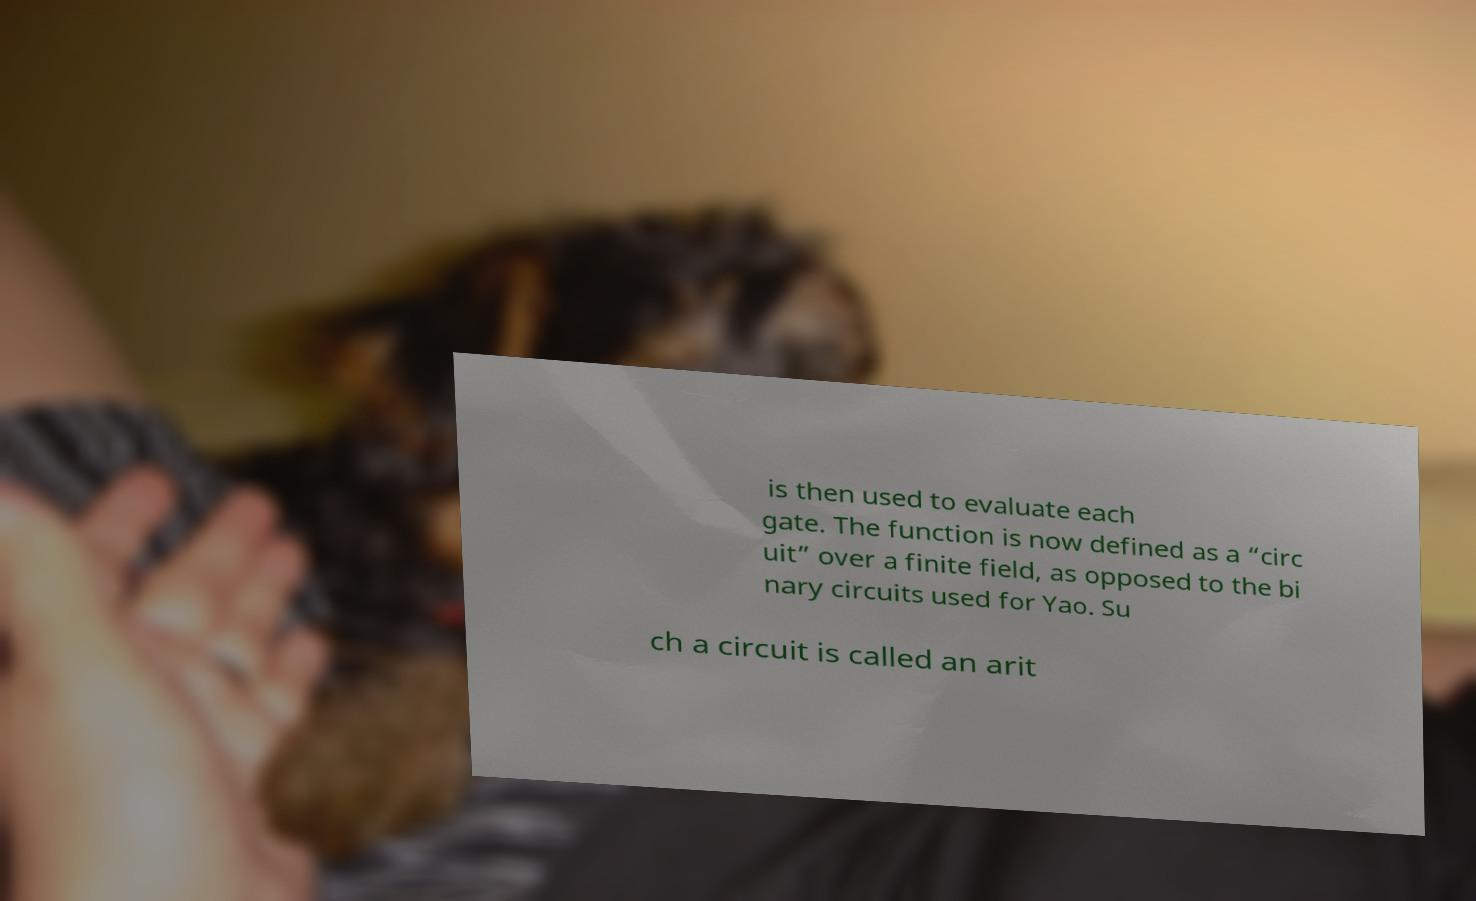Can you accurately transcribe the text from the provided image for me? is then used to evaluate each gate. The function is now defined as a “circ uit” over a finite field, as opposed to the bi nary circuits used for Yao. Su ch a circuit is called an arit 